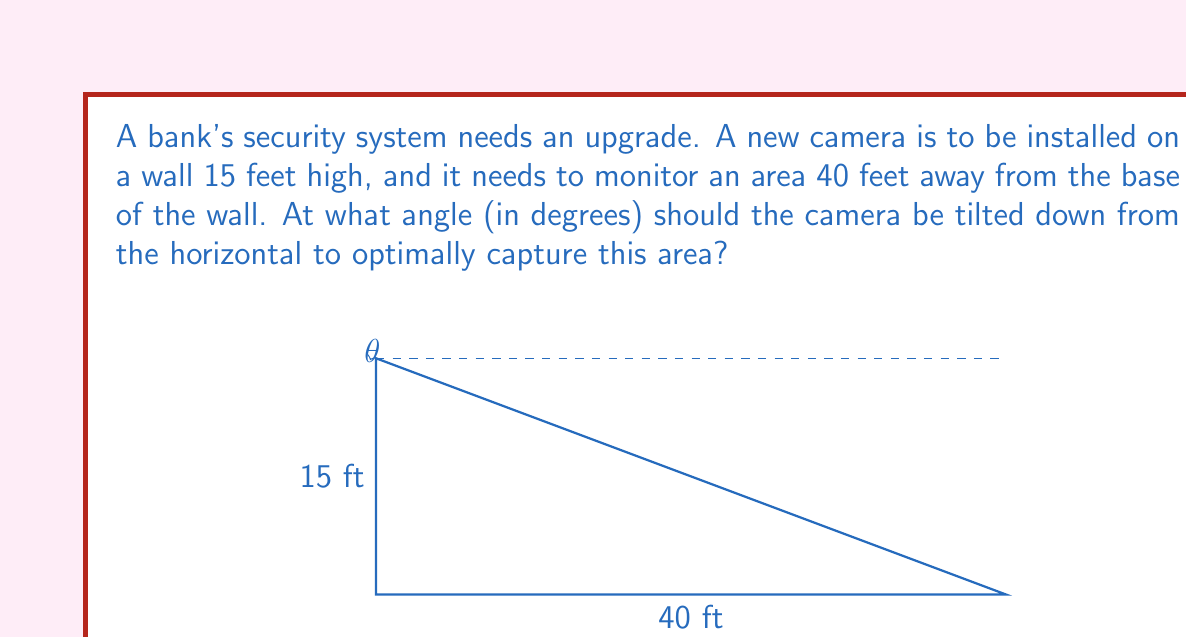Teach me how to tackle this problem. Let's approach this step-by-step:

1) We can visualize this as a right-angled triangle, where:
   - The vertical wall forms one side (15 feet)
   - The distance to the monitored area forms the base (40 feet)
   - The line of sight of the camera forms the hypotenuse

2) We need to find the angle between the horizontal and the line of sight. Let's call this angle θ.

3) In this right-angled triangle, we can use the tangent function:

   $$\tan(\theta) = \frac{\text{opposite}}{\text{adjacent}} = \frac{15}{40}$$

4) To find θ, we need to use the inverse tangent (arctangent) function:

   $$\theta = \arctan(\frac{15}{40})$$

5) Using a calculator or programming function:

   $$\theta = \arctan(0.375) \approx 0.3587 \text{ radians}$$

6) Convert radians to degrees:

   $$\theta \approx 0.3587 \times \frac{180}{\pi} \approx 20.56°$$

Thus, the camera should be tilted down approximately 20.56° from the horizontal.
Answer: $20.56°$ 